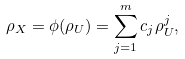Convert formula to latex. <formula><loc_0><loc_0><loc_500><loc_500>\rho _ { X } = \phi ( \rho _ { U } ) = \sum _ { j = 1 } ^ { m } c _ { j } \rho _ { U } ^ { j } ,</formula> 